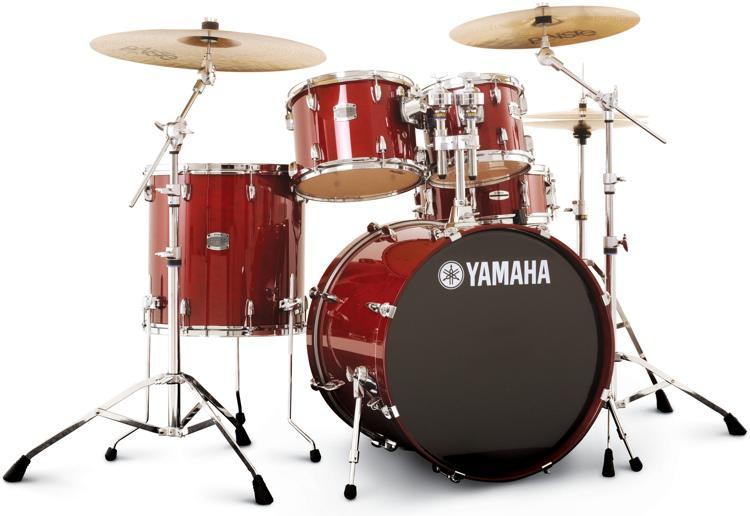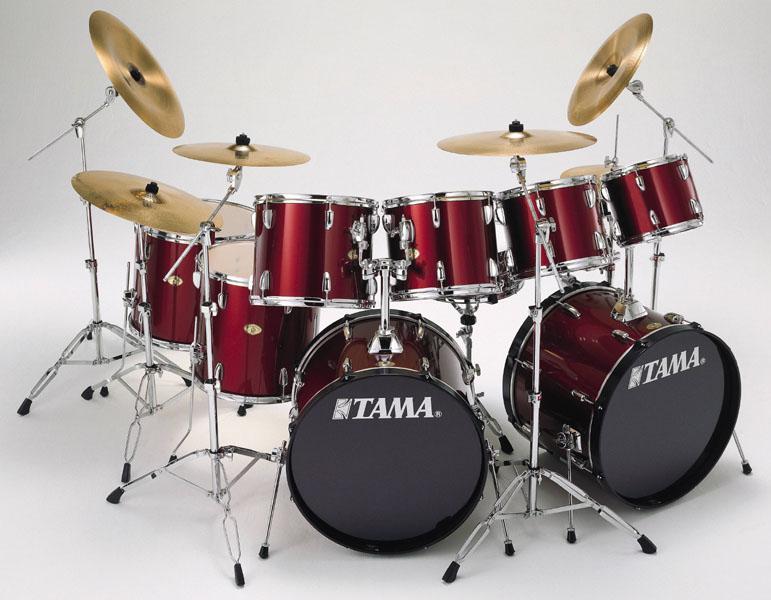The first image is the image on the left, the second image is the image on the right. For the images displayed, is the sentence "The right image contains a drum kit that is predominately red." factually correct? Answer yes or no. Yes. The first image is the image on the left, the second image is the image on the right. Given the left and right images, does the statement "Two drum kits in different sizes are shown, both with red drum facings and at least one forward-facing black drum." hold true? Answer yes or no. Yes. 